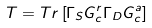<formula> <loc_0><loc_0><loc_500><loc_500>T = T r \left [ \Gamma _ { S } G _ { c } ^ { r } \Gamma _ { D } G _ { c } ^ { a } \right ]</formula> 